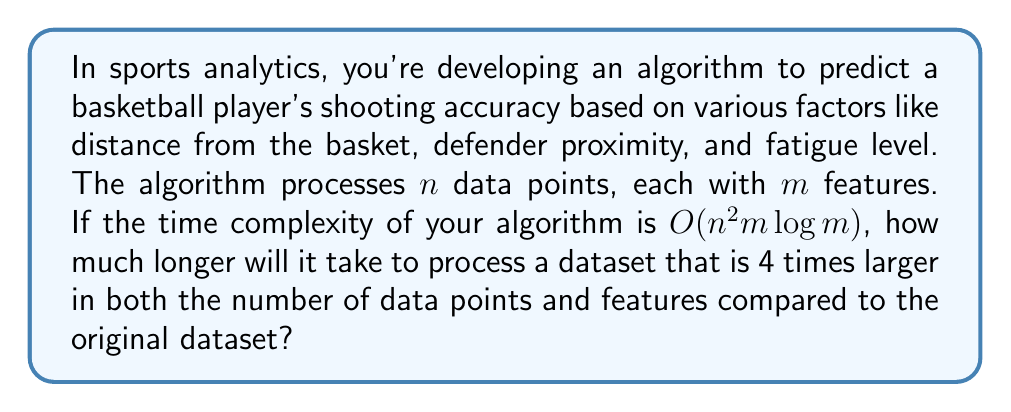Can you answer this question? Let's approach this step-by-step:

1) The original time complexity is $O(n^2m\log m)$.

2) In the new dataset:
   - The number of data points increases from $n$ to $4n$
   - The number of features increases from $m$ to $4m$

3) Let's substitute these new values into the time complexity formula:
   $O((4n)^2(4m)\log(4m))$

4) Simplify the squared term:
   $O(16n^2(4m)\log(4m))$

5) Simplify further:
   $O(64n^2m\log(4m))$

6) Using the logarithm property $\log(4m) = \log(4) + \log(m)$:
   $O(64n^2m(\log(4) + \log(m)))$

7) $\log(4)$ is a constant, so we can simplify to:
   $O(64n^2m\log(m))$

8) The constant factors don't affect big-O notation, so we can remove 64:
   $O(n^2m\log(m))$

9) Comparing this to the original $O(n^2m\log m)$, we see that the form is the same.

10) To find how much longer it will take, we need to compare the actual values:
    $\frac{(4n)^2(4m)\log(4m)}{n^2m\log(m)} = 64 \cdot \frac{\log(4m)}{\log(m)}$

11) $\frac{\log(4m)}{\log(m)}$ is slightly larger than 1 (it approaches 1 as m gets very large), but for simplicity, we can approximate it as 1 for large m.

Therefore, the new dataset will take approximately 64 times longer to process.
Answer: The algorithm will take approximately 64 times longer to process the larger dataset. 